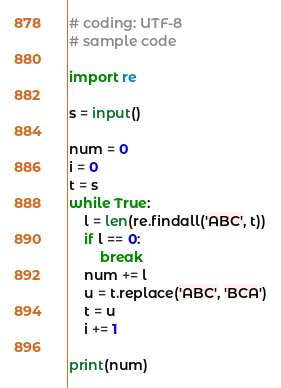Convert code to text. <code><loc_0><loc_0><loc_500><loc_500><_Python_># coding: UTF-8
# sample code

import re

s = input()

num = 0
i = 0
t = s
while True:
	l = len(re.findall('ABC', t))
	if l == 0:
		break
	num += l
	u = t.replace('ABC', 'BCA')
	t = u
	i += 1

print(num)</code> 